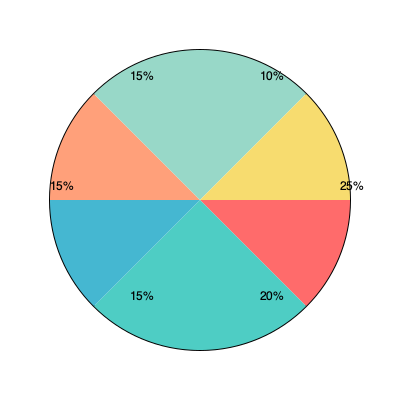Based on the pie chart showing budget allocation for different welfare programs, which two programs combined account for 45% of the total budget, and what strategic implication does this have for rural welfare implementation? To answer this question, we need to analyze the pie chart and follow these steps:

1. Identify the percentages for each segment:
   - 25%
   - 20%
   - 15% (3 segments)
   - 10%

2. Find the combination of two segments that add up to 45%:
   25% + 20% = 45%

3. Strategic implication analysis:
   - The two largest segments account for nearly half of the total budget.
   - This concentration of resources in two programs suggests a focused approach.
   - For rural welfare implementation, this implies:
     a) These two programs are likely the most critical or have the highest impact.
     b) There may be a need to ensure these programs are effectively reaching rural areas.
     c) The remaining 55% is split among four other programs, indicating a more diversified approach for addressing other needs.
     d) Resource allocation in rural areas might need to prioritize infrastructure and delivery mechanisms for the two major programs.
     e) Monitoring and evaluation efforts should be particularly robust for these two programs to ensure efficient use of the significant budget allocation.

4. Conclusion:
   The combination of the 25% and 20% segments, representing 45% of the budget, indicates a strategic focus on two major programs. This has significant implications for rural welfare implementation, requiring careful planning to ensure these programs effectively reach and benefit rural populations while maintaining a balance with other smaller programs.
Answer: 25% and 20% segments; implies focused resource allocation and prioritized implementation of two major programs in rural areas. 